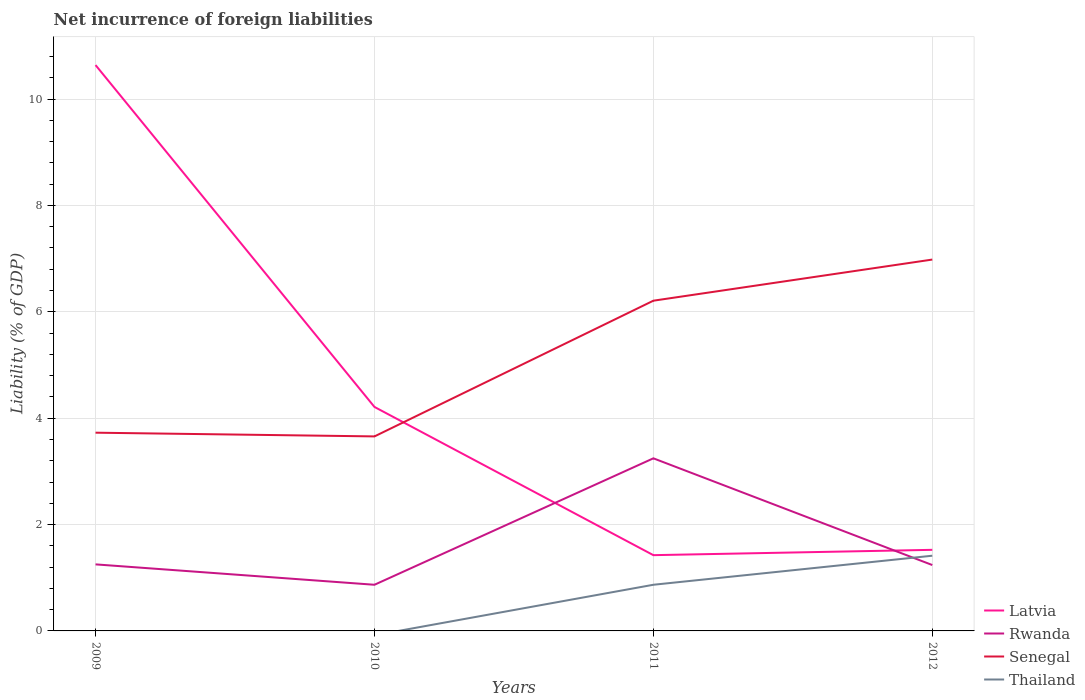Does the line corresponding to Thailand intersect with the line corresponding to Latvia?
Keep it short and to the point. No. Is the number of lines equal to the number of legend labels?
Keep it short and to the point. No. Across all years, what is the maximum net incurrence of foreign liabilities in Latvia?
Your response must be concise. 1.42. What is the total net incurrence of foreign liabilities in Latvia in the graph?
Your response must be concise. 9.21. What is the difference between the highest and the second highest net incurrence of foreign liabilities in Rwanda?
Keep it short and to the point. 2.38. What is the difference between the highest and the lowest net incurrence of foreign liabilities in Latvia?
Provide a succinct answer. 1. How many years are there in the graph?
Give a very brief answer. 4. Are the values on the major ticks of Y-axis written in scientific E-notation?
Make the answer very short. No. Does the graph contain any zero values?
Keep it short and to the point. Yes. Does the graph contain grids?
Make the answer very short. Yes. Where does the legend appear in the graph?
Provide a succinct answer. Bottom right. What is the title of the graph?
Your answer should be compact. Net incurrence of foreign liabilities. Does "Guam" appear as one of the legend labels in the graph?
Offer a very short reply. No. What is the label or title of the X-axis?
Provide a succinct answer. Years. What is the label or title of the Y-axis?
Your response must be concise. Liability (% of GDP). What is the Liability (% of GDP) of Latvia in 2009?
Offer a very short reply. 10.64. What is the Liability (% of GDP) in Rwanda in 2009?
Offer a terse response. 1.25. What is the Liability (% of GDP) in Senegal in 2009?
Make the answer very short. 3.73. What is the Liability (% of GDP) of Latvia in 2010?
Ensure brevity in your answer.  4.21. What is the Liability (% of GDP) in Rwanda in 2010?
Give a very brief answer. 0.87. What is the Liability (% of GDP) of Senegal in 2010?
Your answer should be compact. 3.66. What is the Liability (% of GDP) of Latvia in 2011?
Make the answer very short. 1.42. What is the Liability (% of GDP) of Rwanda in 2011?
Provide a short and direct response. 3.25. What is the Liability (% of GDP) of Senegal in 2011?
Your answer should be compact. 6.21. What is the Liability (% of GDP) of Thailand in 2011?
Ensure brevity in your answer.  0.87. What is the Liability (% of GDP) of Latvia in 2012?
Make the answer very short. 1.52. What is the Liability (% of GDP) in Rwanda in 2012?
Ensure brevity in your answer.  1.24. What is the Liability (% of GDP) of Senegal in 2012?
Make the answer very short. 6.98. What is the Liability (% of GDP) in Thailand in 2012?
Provide a short and direct response. 1.41. Across all years, what is the maximum Liability (% of GDP) of Latvia?
Give a very brief answer. 10.64. Across all years, what is the maximum Liability (% of GDP) of Rwanda?
Your response must be concise. 3.25. Across all years, what is the maximum Liability (% of GDP) of Senegal?
Your response must be concise. 6.98. Across all years, what is the maximum Liability (% of GDP) of Thailand?
Offer a very short reply. 1.41. Across all years, what is the minimum Liability (% of GDP) in Latvia?
Provide a succinct answer. 1.42. Across all years, what is the minimum Liability (% of GDP) of Rwanda?
Your answer should be very brief. 0.87. Across all years, what is the minimum Liability (% of GDP) in Senegal?
Your answer should be compact. 3.66. What is the total Liability (% of GDP) in Latvia in the graph?
Give a very brief answer. 17.8. What is the total Liability (% of GDP) in Rwanda in the graph?
Provide a short and direct response. 6.6. What is the total Liability (% of GDP) in Senegal in the graph?
Give a very brief answer. 20.58. What is the total Liability (% of GDP) of Thailand in the graph?
Your answer should be very brief. 2.28. What is the difference between the Liability (% of GDP) in Latvia in 2009 and that in 2010?
Make the answer very short. 6.43. What is the difference between the Liability (% of GDP) of Rwanda in 2009 and that in 2010?
Ensure brevity in your answer.  0.38. What is the difference between the Liability (% of GDP) in Senegal in 2009 and that in 2010?
Your answer should be very brief. 0.07. What is the difference between the Liability (% of GDP) of Latvia in 2009 and that in 2011?
Provide a short and direct response. 9.21. What is the difference between the Liability (% of GDP) of Rwanda in 2009 and that in 2011?
Your answer should be compact. -1.99. What is the difference between the Liability (% of GDP) in Senegal in 2009 and that in 2011?
Your response must be concise. -2.48. What is the difference between the Liability (% of GDP) of Latvia in 2009 and that in 2012?
Your answer should be compact. 9.11. What is the difference between the Liability (% of GDP) of Rwanda in 2009 and that in 2012?
Ensure brevity in your answer.  0.01. What is the difference between the Liability (% of GDP) in Senegal in 2009 and that in 2012?
Give a very brief answer. -3.26. What is the difference between the Liability (% of GDP) in Latvia in 2010 and that in 2011?
Ensure brevity in your answer.  2.79. What is the difference between the Liability (% of GDP) in Rwanda in 2010 and that in 2011?
Make the answer very short. -2.38. What is the difference between the Liability (% of GDP) in Senegal in 2010 and that in 2011?
Your answer should be compact. -2.55. What is the difference between the Liability (% of GDP) in Latvia in 2010 and that in 2012?
Keep it short and to the point. 2.69. What is the difference between the Liability (% of GDP) of Rwanda in 2010 and that in 2012?
Make the answer very short. -0.37. What is the difference between the Liability (% of GDP) of Senegal in 2010 and that in 2012?
Your answer should be very brief. -3.33. What is the difference between the Liability (% of GDP) in Latvia in 2011 and that in 2012?
Provide a succinct answer. -0.1. What is the difference between the Liability (% of GDP) of Rwanda in 2011 and that in 2012?
Give a very brief answer. 2.01. What is the difference between the Liability (% of GDP) in Senegal in 2011 and that in 2012?
Your response must be concise. -0.77. What is the difference between the Liability (% of GDP) of Thailand in 2011 and that in 2012?
Provide a succinct answer. -0.55. What is the difference between the Liability (% of GDP) of Latvia in 2009 and the Liability (% of GDP) of Rwanda in 2010?
Give a very brief answer. 9.77. What is the difference between the Liability (% of GDP) in Latvia in 2009 and the Liability (% of GDP) in Senegal in 2010?
Give a very brief answer. 6.98. What is the difference between the Liability (% of GDP) of Rwanda in 2009 and the Liability (% of GDP) of Senegal in 2010?
Your response must be concise. -2.41. What is the difference between the Liability (% of GDP) in Latvia in 2009 and the Liability (% of GDP) in Rwanda in 2011?
Your answer should be compact. 7.39. What is the difference between the Liability (% of GDP) of Latvia in 2009 and the Liability (% of GDP) of Senegal in 2011?
Provide a succinct answer. 4.43. What is the difference between the Liability (% of GDP) in Latvia in 2009 and the Liability (% of GDP) in Thailand in 2011?
Give a very brief answer. 9.77. What is the difference between the Liability (% of GDP) of Rwanda in 2009 and the Liability (% of GDP) of Senegal in 2011?
Offer a very short reply. -4.96. What is the difference between the Liability (% of GDP) in Rwanda in 2009 and the Liability (% of GDP) in Thailand in 2011?
Give a very brief answer. 0.38. What is the difference between the Liability (% of GDP) in Senegal in 2009 and the Liability (% of GDP) in Thailand in 2011?
Offer a very short reply. 2.86. What is the difference between the Liability (% of GDP) of Latvia in 2009 and the Liability (% of GDP) of Rwanda in 2012?
Provide a succinct answer. 9.4. What is the difference between the Liability (% of GDP) in Latvia in 2009 and the Liability (% of GDP) in Senegal in 2012?
Make the answer very short. 3.66. What is the difference between the Liability (% of GDP) in Latvia in 2009 and the Liability (% of GDP) in Thailand in 2012?
Your response must be concise. 9.23. What is the difference between the Liability (% of GDP) of Rwanda in 2009 and the Liability (% of GDP) of Senegal in 2012?
Provide a succinct answer. -5.73. What is the difference between the Liability (% of GDP) in Rwanda in 2009 and the Liability (% of GDP) in Thailand in 2012?
Provide a short and direct response. -0.16. What is the difference between the Liability (% of GDP) of Senegal in 2009 and the Liability (% of GDP) of Thailand in 2012?
Your answer should be very brief. 2.31. What is the difference between the Liability (% of GDP) in Latvia in 2010 and the Liability (% of GDP) in Rwanda in 2011?
Keep it short and to the point. 0.97. What is the difference between the Liability (% of GDP) of Latvia in 2010 and the Liability (% of GDP) of Senegal in 2011?
Your answer should be very brief. -2. What is the difference between the Liability (% of GDP) of Latvia in 2010 and the Liability (% of GDP) of Thailand in 2011?
Ensure brevity in your answer.  3.34. What is the difference between the Liability (% of GDP) of Rwanda in 2010 and the Liability (% of GDP) of Senegal in 2011?
Offer a terse response. -5.34. What is the difference between the Liability (% of GDP) of Senegal in 2010 and the Liability (% of GDP) of Thailand in 2011?
Provide a succinct answer. 2.79. What is the difference between the Liability (% of GDP) in Latvia in 2010 and the Liability (% of GDP) in Rwanda in 2012?
Your answer should be very brief. 2.97. What is the difference between the Liability (% of GDP) of Latvia in 2010 and the Liability (% of GDP) of Senegal in 2012?
Give a very brief answer. -2.77. What is the difference between the Liability (% of GDP) in Latvia in 2010 and the Liability (% of GDP) in Thailand in 2012?
Make the answer very short. 2.8. What is the difference between the Liability (% of GDP) in Rwanda in 2010 and the Liability (% of GDP) in Senegal in 2012?
Make the answer very short. -6.11. What is the difference between the Liability (% of GDP) of Rwanda in 2010 and the Liability (% of GDP) of Thailand in 2012?
Offer a terse response. -0.55. What is the difference between the Liability (% of GDP) of Senegal in 2010 and the Liability (% of GDP) of Thailand in 2012?
Provide a succinct answer. 2.24. What is the difference between the Liability (% of GDP) in Latvia in 2011 and the Liability (% of GDP) in Rwanda in 2012?
Make the answer very short. 0.19. What is the difference between the Liability (% of GDP) in Latvia in 2011 and the Liability (% of GDP) in Senegal in 2012?
Give a very brief answer. -5.56. What is the difference between the Liability (% of GDP) of Latvia in 2011 and the Liability (% of GDP) of Thailand in 2012?
Make the answer very short. 0.01. What is the difference between the Liability (% of GDP) of Rwanda in 2011 and the Liability (% of GDP) of Senegal in 2012?
Your answer should be very brief. -3.74. What is the difference between the Liability (% of GDP) in Rwanda in 2011 and the Liability (% of GDP) in Thailand in 2012?
Ensure brevity in your answer.  1.83. What is the difference between the Liability (% of GDP) in Senegal in 2011 and the Liability (% of GDP) in Thailand in 2012?
Your answer should be compact. 4.8. What is the average Liability (% of GDP) in Latvia per year?
Provide a short and direct response. 4.45. What is the average Liability (% of GDP) of Rwanda per year?
Your response must be concise. 1.65. What is the average Liability (% of GDP) in Senegal per year?
Give a very brief answer. 5.14. What is the average Liability (% of GDP) in Thailand per year?
Provide a short and direct response. 0.57. In the year 2009, what is the difference between the Liability (% of GDP) of Latvia and Liability (% of GDP) of Rwanda?
Your answer should be very brief. 9.39. In the year 2009, what is the difference between the Liability (% of GDP) of Latvia and Liability (% of GDP) of Senegal?
Offer a very short reply. 6.91. In the year 2009, what is the difference between the Liability (% of GDP) in Rwanda and Liability (% of GDP) in Senegal?
Offer a very short reply. -2.48. In the year 2010, what is the difference between the Liability (% of GDP) in Latvia and Liability (% of GDP) in Rwanda?
Make the answer very short. 3.34. In the year 2010, what is the difference between the Liability (% of GDP) of Latvia and Liability (% of GDP) of Senegal?
Your response must be concise. 0.55. In the year 2010, what is the difference between the Liability (% of GDP) of Rwanda and Liability (% of GDP) of Senegal?
Keep it short and to the point. -2.79. In the year 2011, what is the difference between the Liability (% of GDP) of Latvia and Liability (% of GDP) of Rwanda?
Your answer should be very brief. -1.82. In the year 2011, what is the difference between the Liability (% of GDP) in Latvia and Liability (% of GDP) in Senegal?
Your answer should be very brief. -4.78. In the year 2011, what is the difference between the Liability (% of GDP) of Latvia and Liability (% of GDP) of Thailand?
Provide a short and direct response. 0.56. In the year 2011, what is the difference between the Liability (% of GDP) of Rwanda and Liability (% of GDP) of Senegal?
Your answer should be very brief. -2.96. In the year 2011, what is the difference between the Liability (% of GDP) of Rwanda and Liability (% of GDP) of Thailand?
Provide a succinct answer. 2.38. In the year 2011, what is the difference between the Liability (% of GDP) of Senegal and Liability (% of GDP) of Thailand?
Give a very brief answer. 5.34. In the year 2012, what is the difference between the Liability (% of GDP) of Latvia and Liability (% of GDP) of Rwanda?
Offer a very short reply. 0.29. In the year 2012, what is the difference between the Liability (% of GDP) in Latvia and Liability (% of GDP) in Senegal?
Provide a short and direct response. -5.46. In the year 2012, what is the difference between the Liability (% of GDP) of Latvia and Liability (% of GDP) of Thailand?
Your response must be concise. 0.11. In the year 2012, what is the difference between the Liability (% of GDP) in Rwanda and Liability (% of GDP) in Senegal?
Your answer should be very brief. -5.74. In the year 2012, what is the difference between the Liability (% of GDP) in Rwanda and Liability (% of GDP) in Thailand?
Offer a terse response. -0.18. In the year 2012, what is the difference between the Liability (% of GDP) of Senegal and Liability (% of GDP) of Thailand?
Keep it short and to the point. 5.57. What is the ratio of the Liability (% of GDP) of Latvia in 2009 to that in 2010?
Make the answer very short. 2.53. What is the ratio of the Liability (% of GDP) of Rwanda in 2009 to that in 2010?
Ensure brevity in your answer.  1.44. What is the ratio of the Liability (% of GDP) of Senegal in 2009 to that in 2010?
Provide a succinct answer. 1.02. What is the ratio of the Liability (% of GDP) of Latvia in 2009 to that in 2011?
Give a very brief answer. 7.47. What is the ratio of the Liability (% of GDP) in Rwanda in 2009 to that in 2011?
Your answer should be compact. 0.39. What is the ratio of the Liability (% of GDP) of Senegal in 2009 to that in 2011?
Offer a terse response. 0.6. What is the ratio of the Liability (% of GDP) of Latvia in 2009 to that in 2012?
Make the answer very short. 6.98. What is the ratio of the Liability (% of GDP) of Rwanda in 2009 to that in 2012?
Ensure brevity in your answer.  1.01. What is the ratio of the Liability (% of GDP) of Senegal in 2009 to that in 2012?
Ensure brevity in your answer.  0.53. What is the ratio of the Liability (% of GDP) of Latvia in 2010 to that in 2011?
Your response must be concise. 2.96. What is the ratio of the Liability (% of GDP) in Rwanda in 2010 to that in 2011?
Provide a succinct answer. 0.27. What is the ratio of the Liability (% of GDP) in Senegal in 2010 to that in 2011?
Make the answer very short. 0.59. What is the ratio of the Liability (% of GDP) in Latvia in 2010 to that in 2012?
Offer a terse response. 2.76. What is the ratio of the Liability (% of GDP) of Rwanda in 2010 to that in 2012?
Ensure brevity in your answer.  0.7. What is the ratio of the Liability (% of GDP) in Senegal in 2010 to that in 2012?
Your response must be concise. 0.52. What is the ratio of the Liability (% of GDP) of Latvia in 2011 to that in 2012?
Offer a very short reply. 0.93. What is the ratio of the Liability (% of GDP) of Rwanda in 2011 to that in 2012?
Provide a short and direct response. 2.62. What is the ratio of the Liability (% of GDP) of Senegal in 2011 to that in 2012?
Make the answer very short. 0.89. What is the ratio of the Liability (% of GDP) of Thailand in 2011 to that in 2012?
Make the answer very short. 0.61. What is the difference between the highest and the second highest Liability (% of GDP) of Latvia?
Your answer should be compact. 6.43. What is the difference between the highest and the second highest Liability (% of GDP) of Rwanda?
Ensure brevity in your answer.  1.99. What is the difference between the highest and the second highest Liability (% of GDP) in Senegal?
Provide a short and direct response. 0.77. What is the difference between the highest and the lowest Liability (% of GDP) in Latvia?
Make the answer very short. 9.21. What is the difference between the highest and the lowest Liability (% of GDP) of Rwanda?
Your response must be concise. 2.38. What is the difference between the highest and the lowest Liability (% of GDP) in Senegal?
Your answer should be very brief. 3.33. What is the difference between the highest and the lowest Liability (% of GDP) of Thailand?
Give a very brief answer. 1.41. 